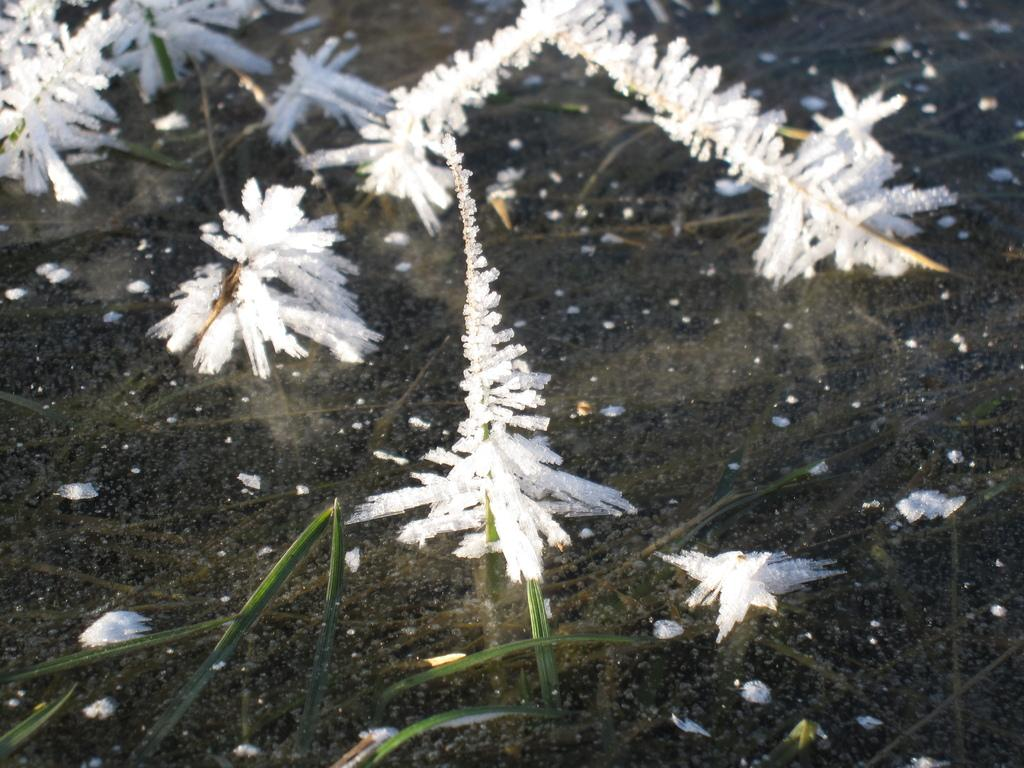What is the condition of the grass in the image? The grass is covered by ice in the image. What can be seen in the background of the image? There is water visible in the background of the image. What type of education is being offered by the hydrant in the image? There is no hydrant present in the image, so it cannot offer any education. 